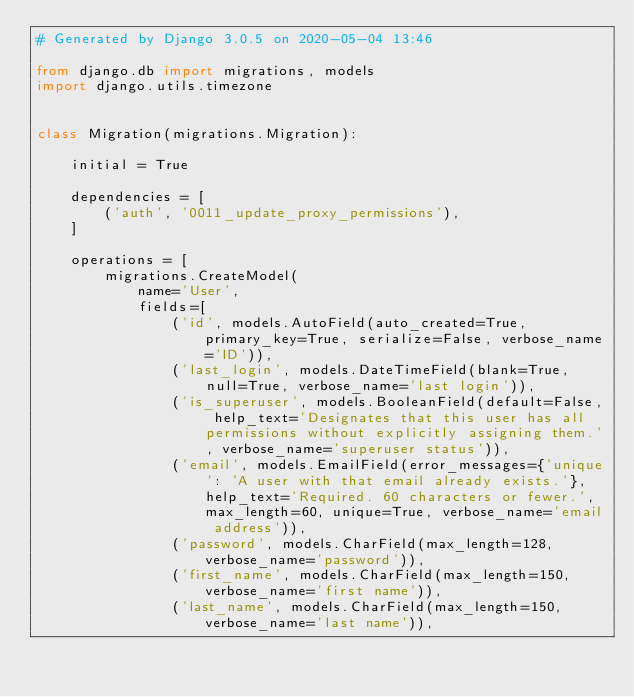<code> <loc_0><loc_0><loc_500><loc_500><_Python_># Generated by Django 3.0.5 on 2020-05-04 13:46

from django.db import migrations, models
import django.utils.timezone


class Migration(migrations.Migration):

    initial = True

    dependencies = [
        ('auth', '0011_update_proxy_permissions'),
    ]

    operations = [
        migrations.CreateModel(
            name='User',
            fields=[
                ('id', models.AutoField(auto_created=True, primary_key=True, serialize=False, verbose_name='ID')),
                ('last_login', models.DateTimeField(blank=True, null=True, verbose_name='last login')),
                ('is_superuser', models.BooleanField(default=False, help_text='Designates that this user has all permissions without explicitly assigning them.', verbose_name='superuser status')),
                ('email', models.EmailField(error_messages={'unique': 'A user with that email already exists.'}, help_text='Required. 60 characters or fewer.', max_length=60, unique=True, verbose_name='email address')),
                ('password', models.CharField(max_length=128, verbose_name='password')),
                ('first_name', models.CharField(max_length=150, verbose_name='first name')),
                ('last_name', models.CharField(max_length=150, verbose_name='last name')),</code> 